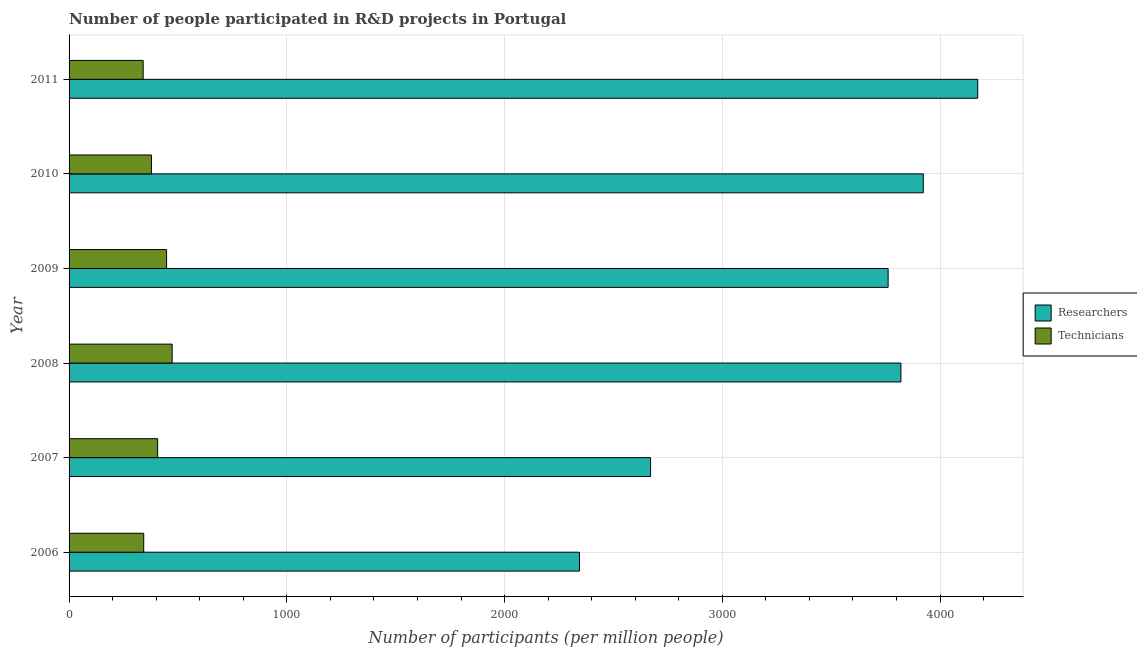How many groups of bars are there?
Offer a very short reply. 6. Are the number of bars on each tick of the Y-axis equal?
Make the answer very short. Yes. What is the label of the 2nd group of bars from the top?
Keep it short and to the point. 2010. What is the number of researchers in 2010?
Offer a very short reply. 3922.91. Across all years, what is the maximum number of technicians?
Keep it short and to the point. 473.42. Across all years, what is the minimum number of researchers?
Make the answer very short. 2344.02. In which year was the number of researchers minimum?
Ensure brevity in your answer.  2006. What is the total number of researchers in the graph?
Your answer should be compact. 2.07e+04. What is the difference between the number of technicians in 2008 and that in 2010?
Your answer should be very brief. 95.13. What is the difference between the number of researchers in 2006 and the number of technicians in 2010?
Your answer should be compact. 1965.73. What is the average number of researchers per year?
Provide a short and direct response. 3448.65. In the year 2008, what is the difference between the number of technicians and number of researchers?
Make the answer very short. -3346.78. In how many years, is the number of researchers greater than 200 ?
Your answer should be very brief. 6. What is the ratio of the number of technicians in 2009 to that in 2011?
Keep it short and to the point. 1.32. What is the difference between the highest and the second highest number of researchers?
Your answer should be compact. 249.95. What is the difference between the highest and the lowest number of researchers?
Give a very brief answer. 1828.84. In how many years, is the number of researchers greater than the average number of researchers taken over all years?
Offer a very short reply. 4. Is the sum of the number of researchers in 2007 and 2009 greater than the maximum number of technicians across all years?
Your answer should be compact. Yes. What does the 2nd bar from the top in 2010 represents?
Give a very brief answer. Researchers. What does the 1st bar from the bottom in 2008 represents?
Ensure brevity in your answer.  Researchers. What is the difference between two consecutive major ticks on the X-axis?
Provide a short and direct response. 1000. Are the values on the major ticks of X-axis written in scientific E-notation?
Your answer should be very brief. No. Does the graph contain any zero values?
Offer a terse response. No. Does the graph contain grids?
Your answer should be compact. Yes. Where does the legend appear in the graph?
Your answer should be very brief. Center right. How are the legend labels stacked?
Give a very brief answer. Vertical. What is the title of the graph?
Keep it short and to the point. Number of people participated in R&D projects in Portugal. Does "Arms exports" appear as one of the legend labels in the graph?
Your answer should be very brief. No. What is the label or title of the X-axis?
Your answer should be very brief. Number of participants (per million people). What is the Number of participants (per million people) of Researchers in 2006?
Ensure brevity in your answer.  2344.02. What is the Number of participants (per million people) of Technicians in 2006?
Give a very brief answer. 342.81. What is the Number of participants (per million people) of Researchers in 2007?
Offer a terse response. 2670.52. What is the Number of participants (per million people) in Technicians in 2007?
Your answer should be very brief. 406.8. What is the Number of participants (per million people) of Researchers in 2008?
Offer a terse response. 3820.2. What is the Number of participants (per million people) of Technicians in 2008?
Your answer should be compact. 473.42. What is the Number of participants (per million people) in Researchers in 2009?
Your answer should be very brief. 3761.39. What is the Number of participants (per million people) in Technicians in 2009?
Provide a short and direct response. 447.8. What is the Number of participants (per million people) of Researchers in 2010?
Ensure brevity in your answer.  3922.91. What is the Number of participants (per million people) in Technicians in 2010?
Ensure brevity in your answer.  378.29. What is the Number of participants (per million people) in Researchers in 2011?
Keep it short and to the point. 4172.86. What is the Number of participants (per million people) in Technicians in 2011?
Keep it short and to the point. 340.22. Across all years, what is the maximum Number of participants (per million people) of Researchers?
Your response must be concise. 4172.86. Across all years, what is the maximum Number of participants (per million people) in Technicians?
Your answer should be very brief. 473.42. Across all years, what is the minimum Number of participants (per million people) of Researchers?
Provide a short and direct response. 2344.02. Across all years, what is the minimum Number of participants (per million people) of Technicians?
Provide a succinct answer. 340.22. What is the total Number of participants (per million people) in Researchers in the graph?
Ensure brevity in your answer.  2.07e+04. What is the total Number of participants (per million people) in Technicians in the graph?
Provide a short and direct response. 2389.34. What is the difference between the Number of participants (per million people) in Researchers in 2006 and that in 2007?
Ensure brevity in your answer.  -326.5. What is the difference between the Number of participants (per million people) in Technicians in 2006 and that in 2007?
Provide a short and direct response. -63.99. What is the difference between the Number of participants (per million people) of Researchers in 2006 and that in 2008?
Provide a short and direct response. -1476.17. What is the difference between the Number of participants (per million people) in Technicians in 2006 and that in 2008?
Ensure brevity in your answer.  -130.61. What is the difference between the Number of participants (per million people) in Researchers in 2006 and that in 2009?
Provide a short and direct response. -1417.37. What is the difference between the Number of participants (per million people) of Technicians in 2006 and that in 2009?
Keep it short and to the point. -104.99. What is the difference between the Number of participants (per million people) of Researchers in 2006 and that in 2010?
Provide a short and direct response. -1578.89. What is the difference between the Number of participants (per million people) of Technicians in 2006 and that in 2010?
Keep it short and to the point. -35.48. What is the difference between the Number of participants (per million people) in Researchers in 2006 and that in 2011?
Your answer should be very brief. -1828.84. What is the difference between the Number of participants (per million people) in Technicians in 2006 and that in 2011?
Provide a succinct answer. 2.6. What is the difference between the Number of participants (per million people) of Researchers in 2007 and that in 2008?
Your answer should be very brief. -1149.67. What is the difference between the Number of participants (per million people) in Technicians in 2007 and that in 2008?
Provide a succinct answer. -66.62. What is the difference between the Number of participants (per million people) in Researchers in 2007 and that in 2009?
Make the answer very short. -1090.87. What is the difference between the Number of participants (per million people) in Technicians in 2007 and that in 2009?
Keep it short and to the point. -41. What is the difference between the Number of participants (per million people) in Researchers in 2007 and that in 2010?
Offer a very short reply. -1252.39. What is the difference between the Number of participants (per million people) of Technicians in 2007 and that in 2010?
Provide a short and direct response. 28.51. What is the difference between the Number of participants (per million people) in Researchers in 2007 and that in 2011?
Ensure brevity in your answer.  -1502.34. What is the difference between the Number of participants (per million people) of Technicians in 2007 and that in 2011?
Make the answer very short. 66.59. What is the difference between the Number of participants (per million people) of Researchers in 2008 and that in 2009?
Provide a succinct answer. 58.8. What is the difference between the Number of participants (per million people) of Technicians in 2008 and that in 2009?
Make the answer very short. 25.62. What is the difference between the Number of participants (per million people) of Researchers in 2008 and that in 2010?
Give a very brief answer. -102.72. What is the difference between the Number of participants (per million people) in Technicians in 2008 and that in 2010?
Your answer should be compact. 95.13. What is the difference between the Number of participants (per million people) of Researchers in 2008 and that in 2011?
Make the answer very short. -352.67. What is the difference between the Number of participants (per million people) in Technicians in 2008 and that in 2011?
Your answer should be very brief. 133.2. What is the difference between the Number of participants (per million people) of Researchers in 2009 and that in 2010?
Keep it short and to the point. -161.52. What is the difference between the Number of participants (per million people) of Technicians in 2009 and that in 2010?
Provide a succinct answer. 69.51. What is the difference between the Number of participants (per million people) of Researchers in 2009 and that in 2011?
Your answer should be compact. -411.47. What is the difference between the Number of participants (per million people) of Technicians in 2009 and that in 2011?
Provide a short and direct response. 107.58. What is the difference between the Number of participants (per million people) of Researchers in 2010 and that in 2011?
Ensure brevity in your answer.  -249.95. What is the difference between the Number of participants (per million people) of Technicians in 2010 and that in 2011?
Make the answer very short. 38.08. What is the difference between the Number of participants (per million people) of Researchers in 2006 and the Number of participants (per million people) of Technicians in 2007?
Give a very brief answer. 1937.22. What is the difference between the Number of participants (per million people) of Researchers in 2006 and the Number of participants (per million people) of Technicians in 2008?
Your response must be concise. 1870.61. What is the difference between the Number of participants (per million people) of Researchers in 2006 and the Number of participants (per million people) of Technicians in 2009?
Offer a very short reply. 1896.22. What is the difference between the Number of participants (per million people) in Researchers in 2006 and the Number of participants (per million people) in Technicians in 2010?
Provide a short and direct response. 1965.73. What is the difference between the Number of participants (per million people) in Researchers in 2006 and the Number of participants (per million people) in Technicians in 2011?
Your response must be concise. 2003.81. What is the difference between the Number of participants (per million people) in Researchers in 2007 and the Number of participants (per million people) in Technicians in 2008?
Offer a very short reply. 2197.11. What is the difference between the Number of participants (per million people) in Researchers in 2007 and the Number of participants (per million people) in Technicians in 2009?
Your answer should be very brief. 2222.73. What is the difference between the Number of participants (per million people) of Researchers in 2007 and the Number of participants (per million people) of Technicians in 2010?
Give a very brief answer. 2292.23. What is the difference between the Number of participants (per million people) of Researchers in 2007 and the Number of participants (per million people) of Technicians in 2011?
Provide a succinct answer. 2330.31. What is the difference between the Number of participants (per million people) in Researchers in 2008 and the Number of participants (per million people) in Technicians in 2009?
Your response must be concise. 3372.4. What is the difference between the Number of participants (per million people) in Researchers in 2008 and the Number of participants (per million people) in Technicians in 2010?
Offer a very short reply. 3441.9. What is the difference between the Number of participants (per million people) of Researchers in 2008 and the Number of participants (per million people) of Technicians in 2011?
Make the answer very short. 3479.98. What is the difference between the Number of participants (per million people) of Researchers in 2009 and the Number of participants (per million people) of Technicians in 2010?
Give a very brief answer. 3383.1. What is the difference between the Number of participants (per million people) of Researchers in 2009 and the Number of participants (per million people) of Technicians in 2011?
Your answer should be compact. 3421.18. What is the difference between the Number of participants (per million people) in Researchers in 2010 and the Number of participants (per million people) in Technicians in 2011?
Keep it short and to the point. 3582.7. What is the average Number of participants (per million people) in Researchers per year?
Give a very brief answer. 3448.65. What is the average Number of participants (per million people) of Technicians per year?
Ensure brevity in your answer.  398.22. In the year 2006, what is the difference between the Number of participants (per million people) in Researchers and Number of participants (per million people) in Technicians?
Make the answer very short. 2001.21. In the year 2007, what is the difference between the Number of participants (per million people) of Researchers and Number of participants (per million people) of Technicians?
Keep it short and to the point. 2263.72. In the year 2008, what is the difference between the Number of participants (per million people) in Researchers and Number of participants (per million people) in Technicians?
Give a very brief answer. 3346.78. In the year 2009, what is the difference between the Number of participants (per million people) of Researchers and Number of participants (per million people) of Technicians?
Ensure brevity in your answer.  3313.6. In the year 2010, what is the difference between the Number of participants (per million people) in Researchers and Number of participants (per million people) in Technicians?
Your answer should be compact. 3544.62. In the year 2011, what is the difference between the Number of participants (per million people) in Researchers and Number of participants (per million people) in Technicians?
Offer a terse response. 3832.65. What is the ratio of the Number of participants (per million people) in Researchers in 2006 to that in 2007?
Make the answer very short. 0.88. What is the ratio of the Number of participants (per million people) of Technicians in 2006 to that in 2007?
Your answer should be compact. 0.84. What is the ratio of the Number of participants (per million people) of Researchers in 2006 to that in 2008?
Offer a very short reply. 0.61. What is the ratio of the Number of participants (per million people) in Technicians in 2006 to that in 2008?
Offer a very short reply. 0.72. What is the ratio of the Number of participants (per million people) of Researchers in 2006 to that in 2009?
Offer a terse response. 0.62. What is the ratio of the Number of participants (per million people) of Technicians in 2006 to that in 2009?
Your answer should be compact. 0.77. What is the ratio of the Number of participants (per million people) of Researchers in 2006 to that in 2010?
Provide a succinct answer. 0.6. What is the ratio of the Number of participants (per million people) in Technicians in 2006 to that in 2010?
Make the answer very short. 0.91. What is the ratio of the Number of participants (per million people) in Researchers in 2006 to that in 2011?
Your answer should be compact. 0.56. What is the ratio of the Number of participants (per million people) in Technicians in 2006 to that in 2011?
Offer a terse response. 1.01. What is the ratio of the Number of participants (per million people) in Researchers in 2007 to that in 2008?
Ensure brevity in your answer.  0.7. What is the ratio of the Number of participants (per million people) of Technicians in 2007 to that in 2008?
Offer a terse response. 0.86. What is the ratio of the Number of participants (per million people) of Researchers in 2007 to that in 2009?
Provide a short and direct response. 0.71. What is the ratio of the Number of participants (per million people) in Technicians in 2007 to that in 2009?
Your answer should be very brief. 0.91. What is the ratio of the Number of participants (per million people) of Researchers in 2007 to that in 2010?
Offer a terse response. 0.68. What is the ratio of the Number of participants (per million people) in Technicians in 2007 to that in 2010?
Keep it short and to the point. 1.08. What is the ratio of the Number of participants (per million people) of Researchers in 2007 to that in 2011?
Give a very brief answer. 0.64. What is the ratio of the Number of participants (per million people) of Technicians in 2007 to that in 2011?
Make the answer very short. 1.2. What is the ratio of the Number of participants (per million people) in Researchers in 2008 to that in 2009?
Make the answer very short. 1.02. What is the ratio of the Number of participants (per million people) in Technicians in 2008 to that in 2009?
Offer a very short reply. 1.06. What is the ratio of the Number of participants (per million people) of Researchers in 2008 to that in 2010?
Give a very brief answer. 0.97. What is the ratio of the Number of participants (per million people) in Technicians in 2008 to that in 2010?
Offer a terse response. 1.25. What is the ratio of the Number of participants (per million people) of Researchers in 2008 to that in 2011?
Make the answer very short. 0.92. What is the ratio of the Number of participants (per million people) of Technicians in 2008 to that in 2011?
Provide a short and direct response. 1.39. What is the ratio of the Number of participants (per million people) in Researchers in 2009 to that in 2010?
Give a very brief answer. 0.96. What is the ratio of the Number of participants (per million people) in Technicians in 2009 to that in 2010?
Your response must be concise. 1.18. What is the ratio of the Number of participants (per million people) of Researchers in 2009 to that in 2011?
Your answer should be very brief. 0.9. What is the ratio of the Number of participants (per million people) in Technicians in 2009 to that in 2011?
Make the answer very short. 1.32. What is the ratio of the Number of participants (per million people) of Researchers in 2010 to that in 2011?
Your response must be concise. 0.94. What is the ratio of the Number of participants (per million people) in Technicians in 2010 to that in 2011?
Offer a terse response. 1.11. What is the difference between the highest and the second highest Number of participants (per million people) in Researchers?
Offer a very short reply. 249.95. What is the difference between the highest and the second highest Number of participants (per million people) in Technicians?
Provide a succinct answer. 25.62. What is the difference between the highest and the lowest Number of participants (per million people) of Researchers?
Offer a very short reply. 1828.84. What is the difference between the highest and the lowest Number of participants (per million people) of Technicians?
Your answer should be very brief. 133.2. 